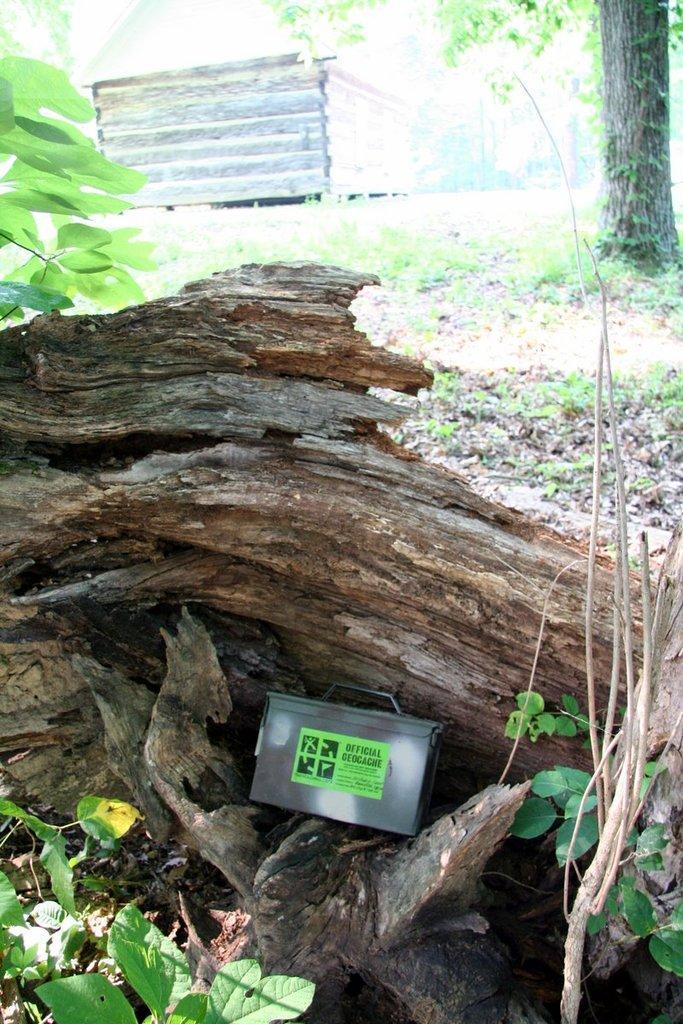Describe this image in one or two sentences. In the foreground of the picture there are plants and wooden trunk. In the middle of the picture there are plants and the trunk of a tree. In the background there is an object and it is not clear. 